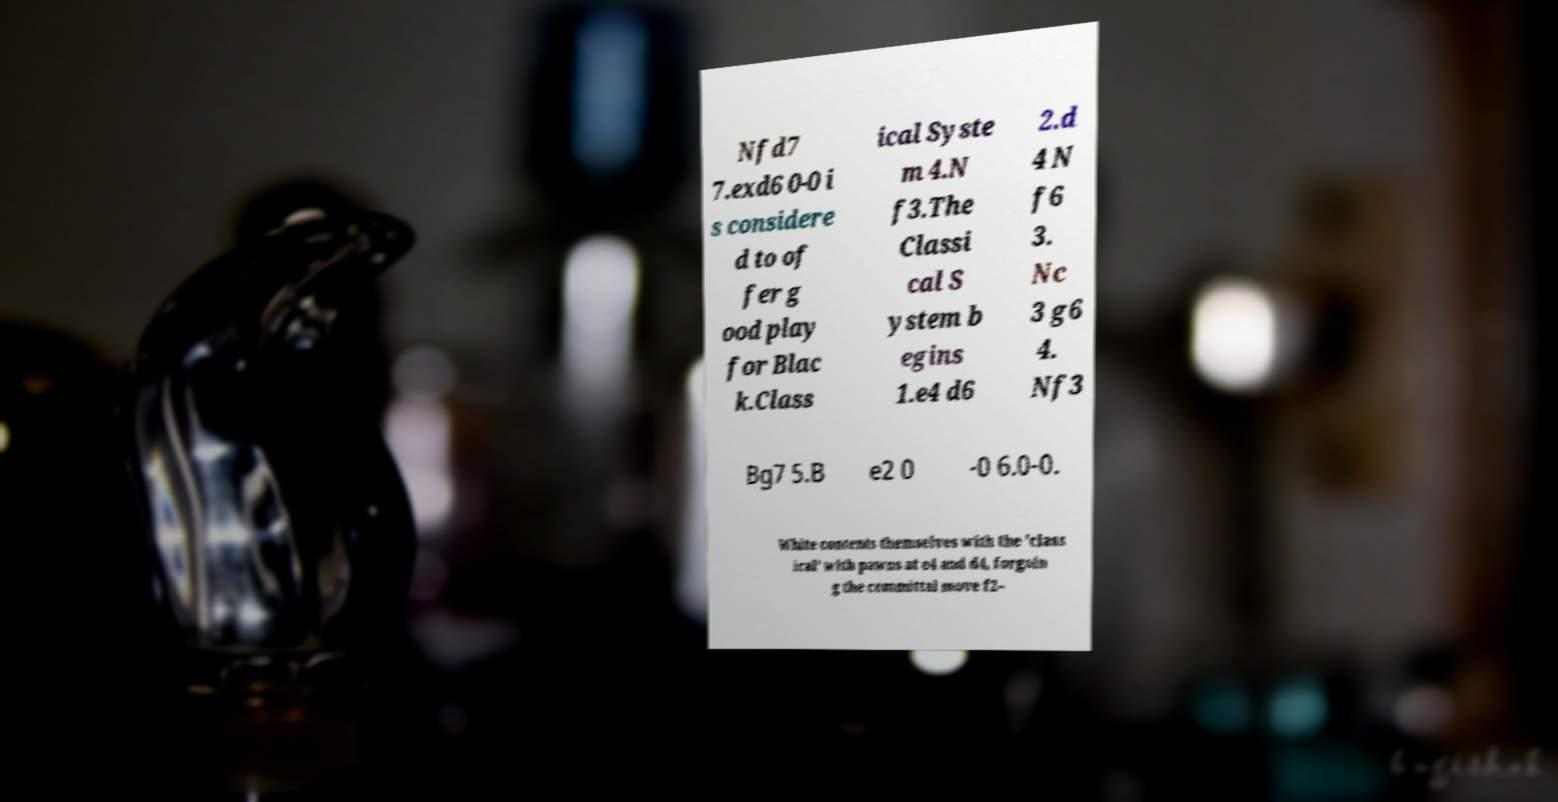Please read and relay the text visible in this image. What does it say? Nfd7 7.exd6 0-0 i s considere d to of fer g ood play for Blac k.Class ical Syste m 4.N f3.The Classi cal S ystem b egins 1.e4 d6 2.d 4 N f6 3. Nc 3 g6 4. Nf3 Bg7 5.B e2 0 -0 6.0-0. White contents themselves with the 'class ical' with pawns at e4 and d4, forgoin g the committal move f2– 